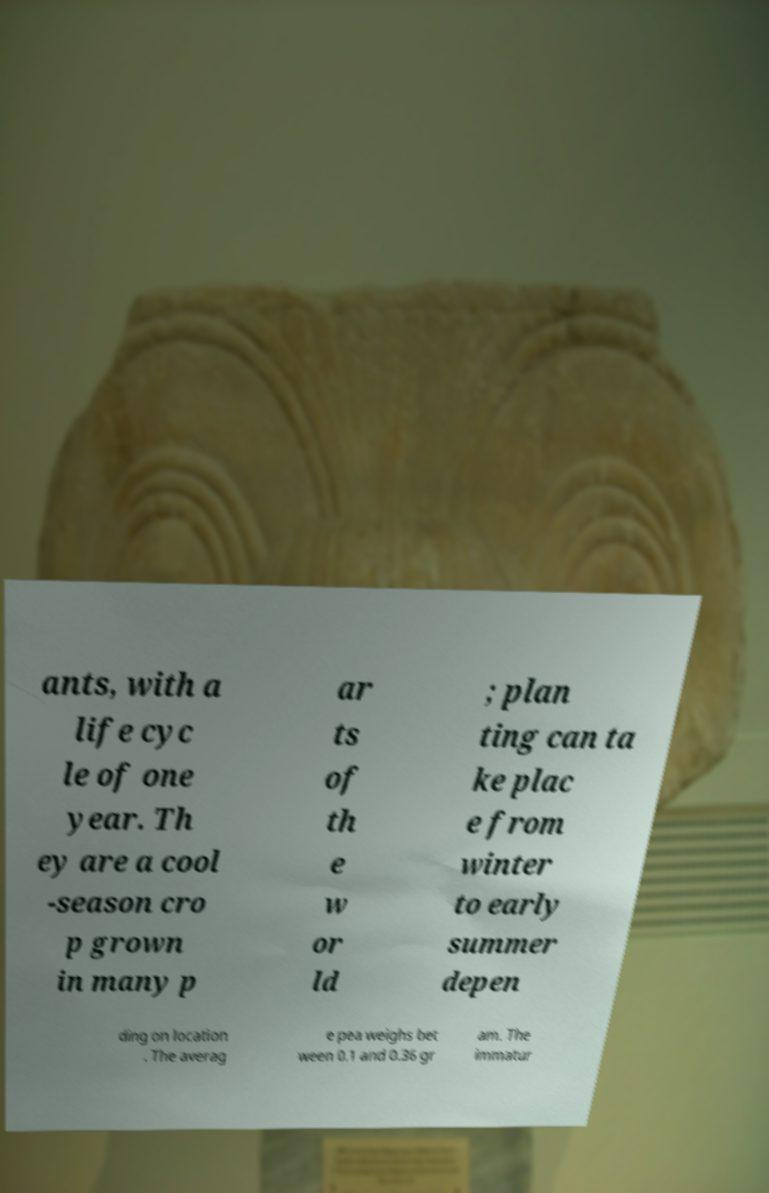Can you accurately transcribe the text from the provided image for me? ants, with a life cyc le of one year. Th ey are a cool -season cro p grown in many p ar ts of th e w or ld ; plan ting can ta ke plac e from winter to early summer depen ding on location . The averag e pea weighs bet ween 0.1 and 0.36 gr am. The immatur 